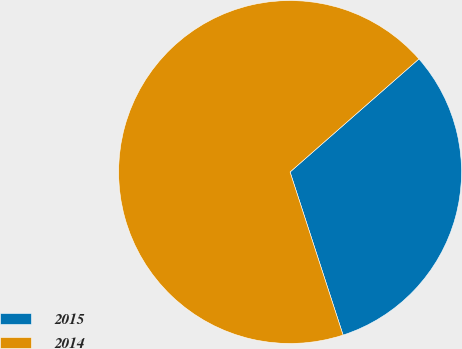<chart> <loc_0><loc_0><loc_500><loc_500><pie_chart><fcel>2015<fcel>2014<nl><fcel>31.46%<fcel>68.54%<nl></chart> 